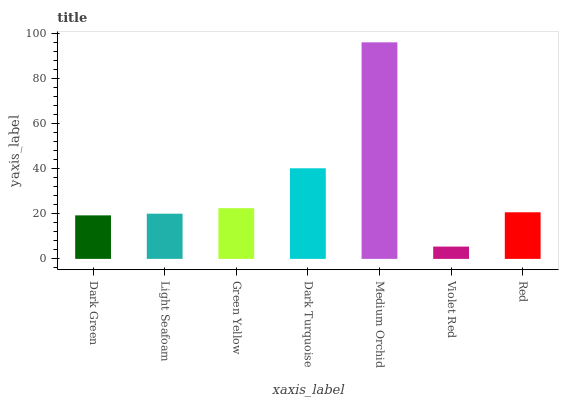Is Violet Red the minimum?
Answer yes or no. Yes. Is Medium Orchid the maximum?
Answer yes or no. Yes. Is Light Seafoam the minimum?
Answer yes or no. No. Is Light Seafoam the maximum?
Answer yes or no. No. Is Light Seafoam greater than Dark Green?
Answer yes or no. Yes. Is Dark Green less than Light Seafoam?
Answer yes or no. Yes. Is Dark Green greater than Light Seafoam?
Answer yes or no. No. Is Light Seafoam less than Dark Green?
Answer yes or no. No. Is Red the high median?
Answer yes or no. Yes. Is Red the low median?
Answer yes or no. Yes. Is Dark Turquoise the high median?
Answer yes or no. No. Is Medium Orchid the low median?
Answer yes or no. No. 